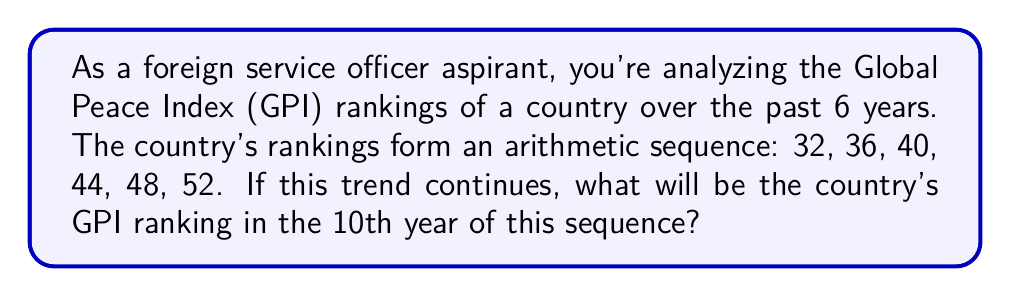Could you help me with this problem? Let's approach this step-by-step:

1) First, we need to identify the pattern in the sequence. We can see that each term increases by 4 from the previous term. This is an arithmetic sequence with a common difference of 4.

2) We can express the nth term of an arithmetic sequence using the formula:

   $$a_n = a_1 + (n-1)d$$

   Where $a_n$ is the nth term, $a_1$ is the first term, n is the position of the term, and d is the common difference.

3) In this case:
   $a_1 = 32$ (first term)
   $d = 4$ (common difference)

4) We want to find the 10th term, so n = 10.

5) Let's substitute these values into our formula:

   $$a_{10} = 32 + (10-1)4$$

6) Simplify:
   $$a_{10} = 32 + 36 = 68$$

Therefore, if the trend continues, in the 10th year, the country's GPI ranking will be 68.
Answer: 68 